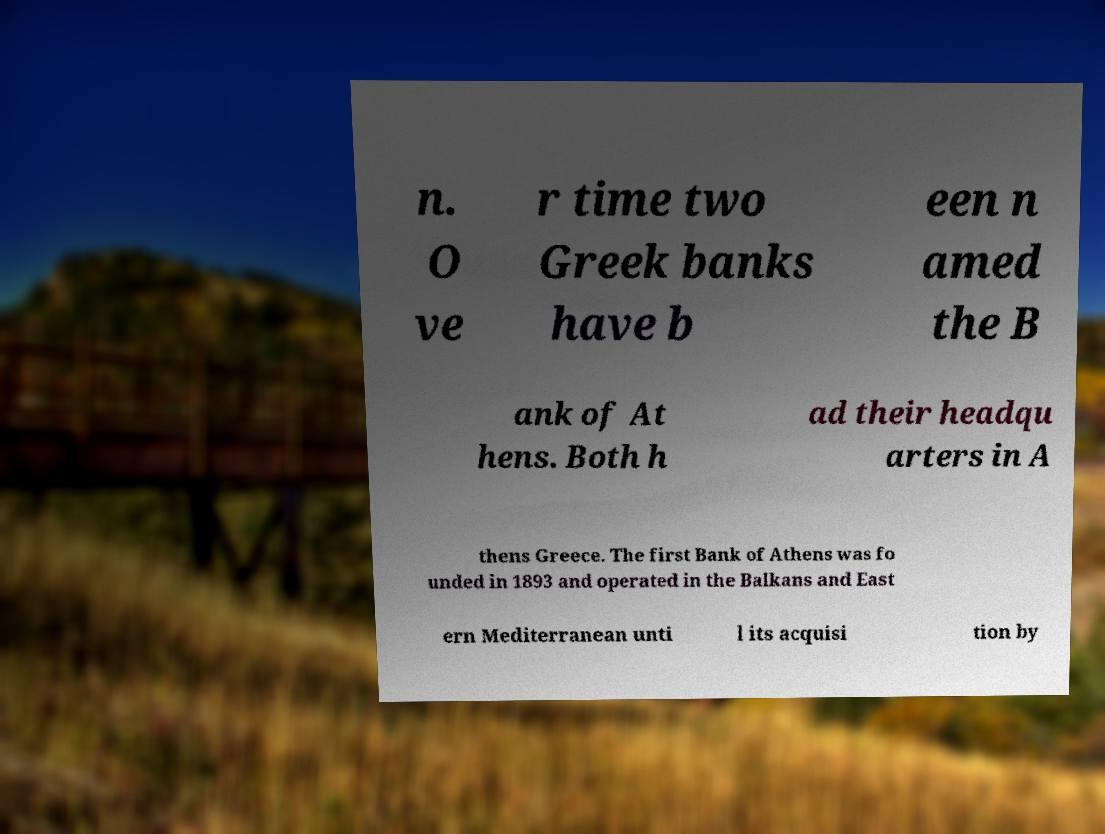Please read and relay the text visible in this image. What does it say? n. O ve r time two Greek banks have b een n amed the B ank of At hens. Both h ad their headqu arters in A thens Greece. The first Bank of Athens was fo unded in 1893 and operated in the Balkans and East ern Mediterranean unti l its acquisi tion by 